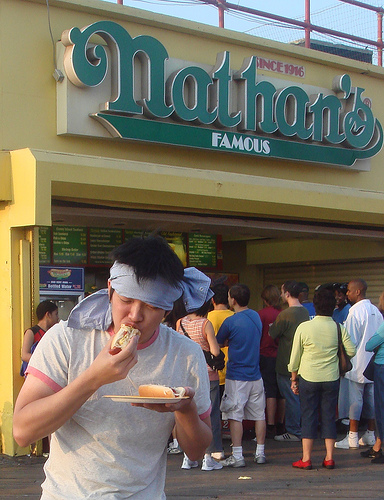<image>
Is there a bandana on the man? Yes. Looking at the image, I can see the bandana is positioned on top of the man, with the man providing support. 